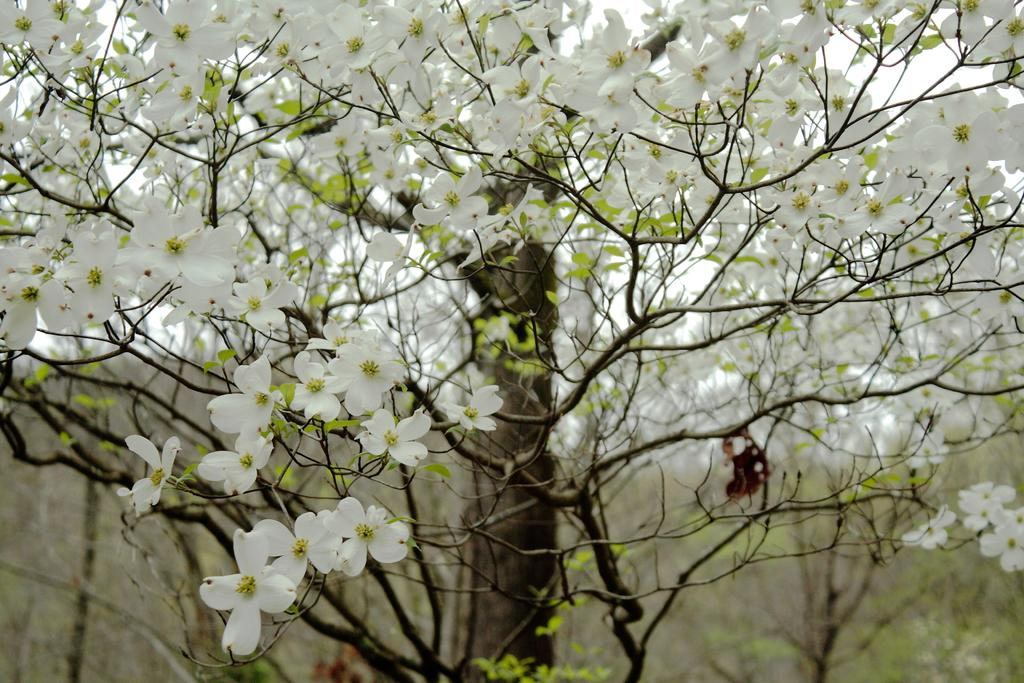What type of plants can be seen in the image? There are flowers in the image. What can be seen in the background of the image? There are trees in the background of the image. How many clovers are visible in the image? There are no clovers present in the image; it features flowers and trees. What route do the squirrels take to climb the trees in the image? There are no squirrels present in the image, so it is not possible to determine their route for climbing the trees. 